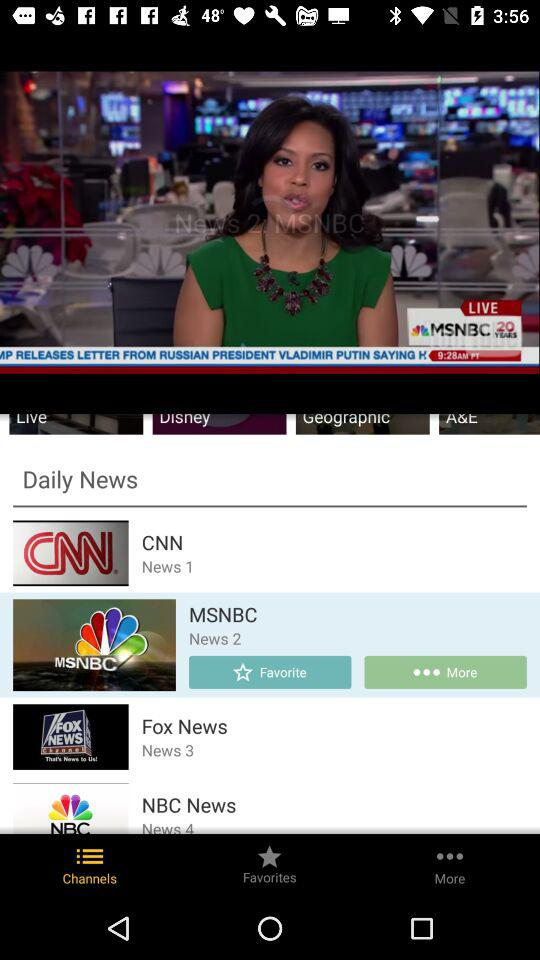Which tab is currently selected? The currently selected tab is "Channels". 